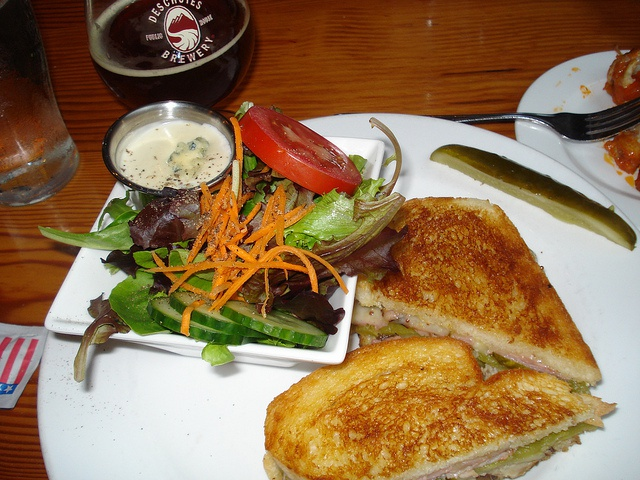Describe the objects in this image and their specific colors. I can see dining table in black and maroon tones, sandwich in black, red, orange, and tan tones, sandwich in black, brown, tan, and maroon tones, cup in black, maroon, and gray tones, and bottle in black, maroon, and gray tones in this image. 